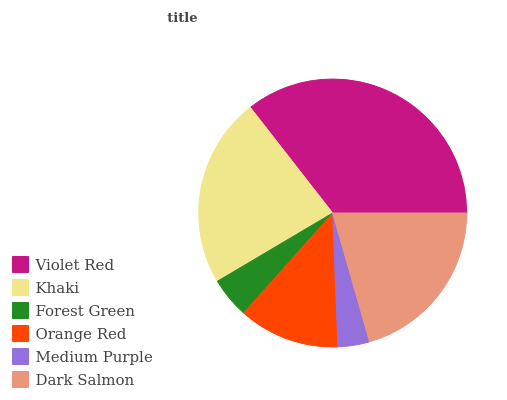Is Medium Purple the minimum?
Answer yes or no. Yes. Is Violet Red the maximum?
Answer yes or no. Yes. Is Khaki the minimum?
Answer yes or no. No. Is Khaki the maximum?
Answer yes or no. No. Is Violet Red greater than Khaki?
Answer yes or no. Yes. Is Khaki less than Violet Red?
Answer yes or no. Yes. Is Khaki greater than Violet Red?
Answer yes or no. No. Is Violet Red less than Khaki?
Answer yes or no. No. Is Dark Salmon the high median?
Answer yes or no. Yes. Is Orange Red the low median?
Answer yes or no. Yes. Is Khaki the high median?
Answer yes or no. No. Is Medium Purple the low median?
Answer yes or no. No. 